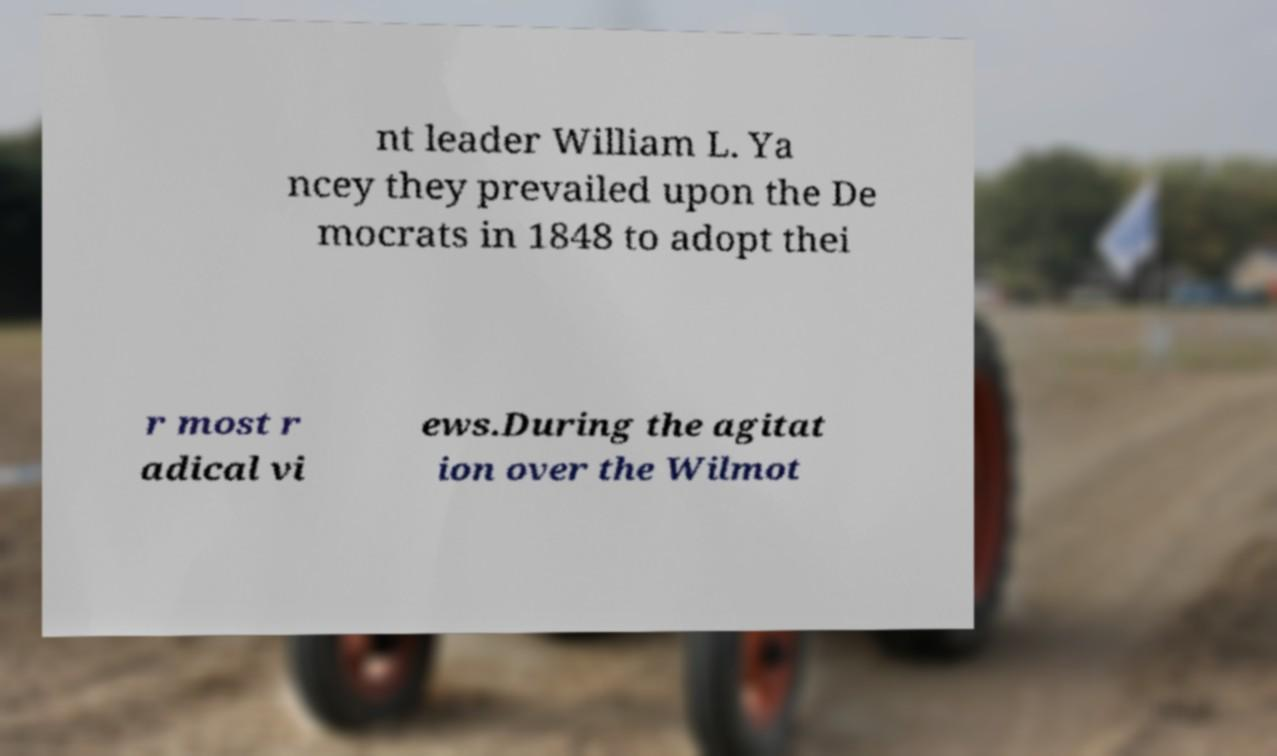Can you accurately transcribe the text from the provided image for me? nt leader William L. Ya ncey they prevailed upon the De mocrats in 1848 to adopt thei r most r adical vi ews.During the agitat ion over the Wilmot 